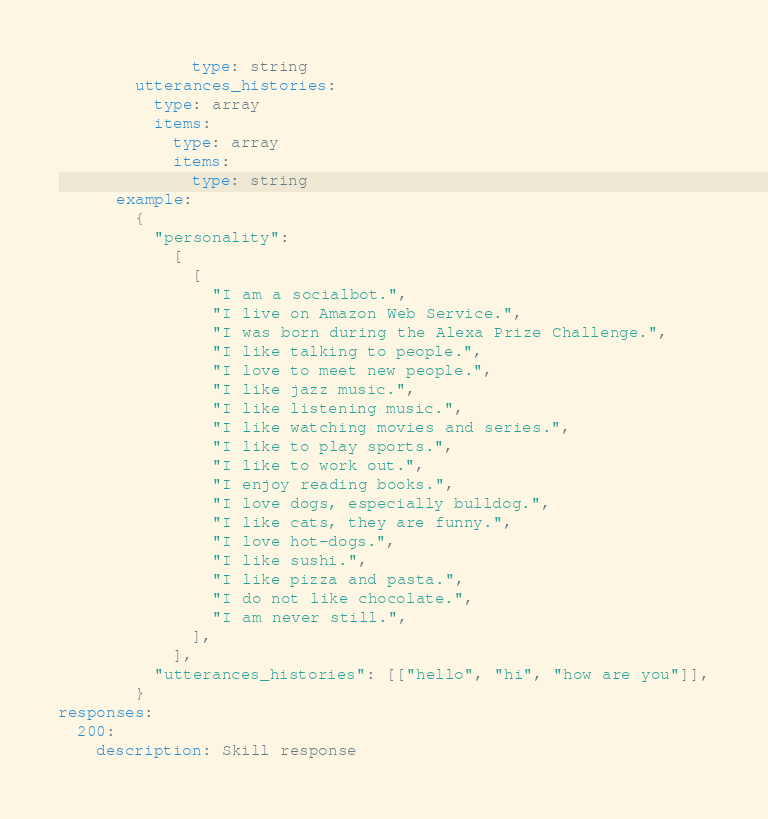<code> <loc_0><loc_0><loc_500><loc_500><_YAML_>              type: string
        utterances_histories:
          type: array
          items:
            type: array
            items:
              type: string
      example:
        {
          "personality":
            [
              [
                "I am a socialbot.",
                "I live on Amazon Web Service.",
                "I was born during the Alexa Prize Challenge.",
                "I like talking to people.",
                "I love to meet new people.",
                "I like jazz music.",
                "I like listening music.",
                "I like watching movies and series.",
                "I like to play sports.",
                "I like to work out.",
                "I enjoy reading books.",
                "I love dogs, especially bulldog.",
                "I like cats, they are funny.",
                "I love hot-dogs.",
                "I like sushi.",
                "I like pizza and pasta.",
                "I do not like chocolate.",
                "I am never still.",
              ],
            ],
          "utterances_histories": [["hello", "hi", "how are you"]],
        }
responses:
  200:
    description: Skill response
</code> 